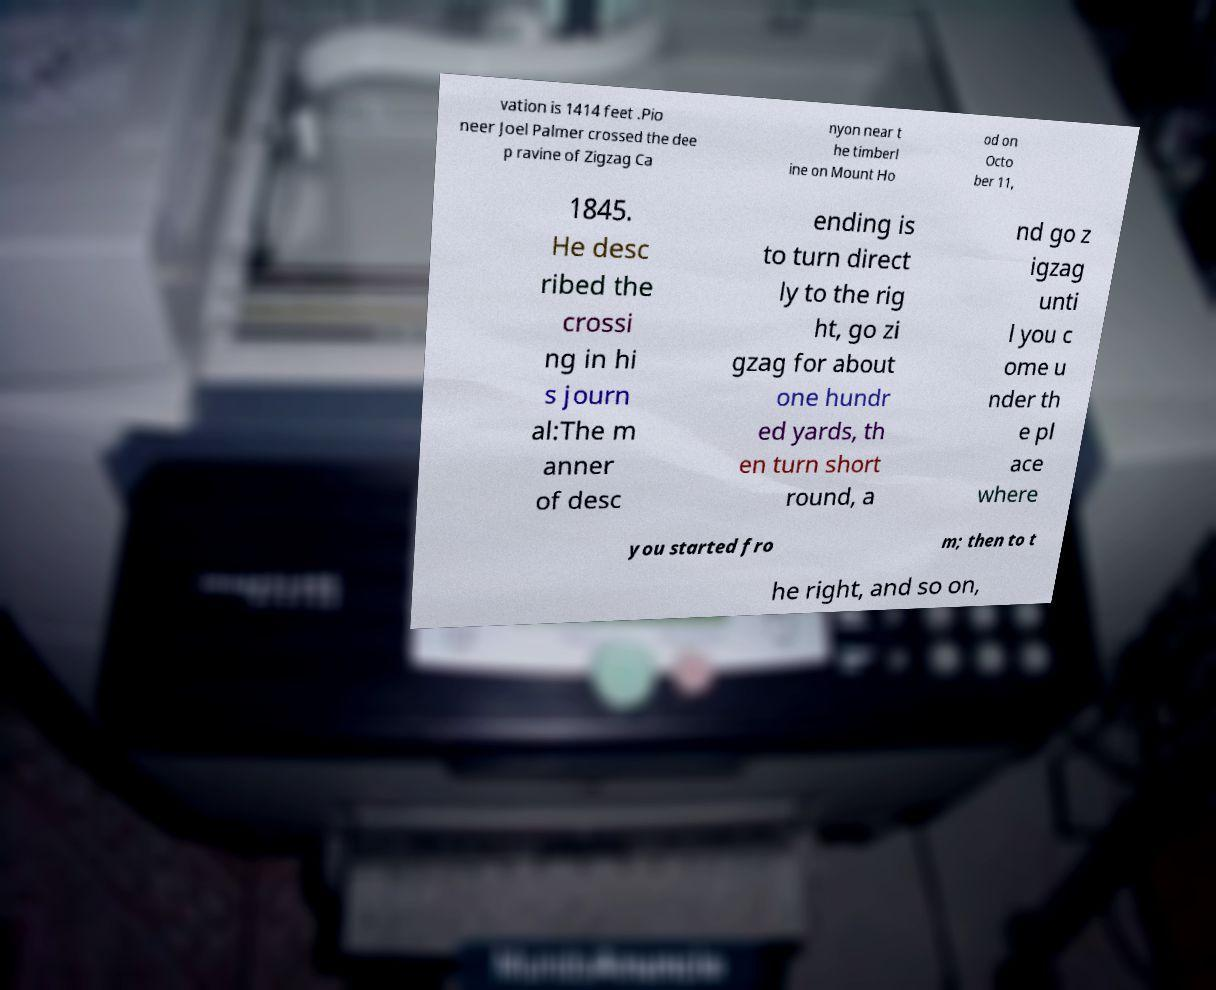Can you read and provide the text displayed in the image?This photo seems to have some interesting text. Can you extract and type it out for me? vation is 1414 feet .Pio neer Joel Palmer crossed the dee p ravine of Zigzag Ca nyon near t he timberl ine on Mount Ho od on Octo ber 11, 1845. He desc ribed the crossi ng in hi s journ al:The m anner of desc ending is to turn direct ly to the rig ht, go zi gzag for about one hundr ed yards, th en turn short round, a nd go z igzag unti l you c ome u nder th e pl ace where you started fro m; then to t he right, and so on, 